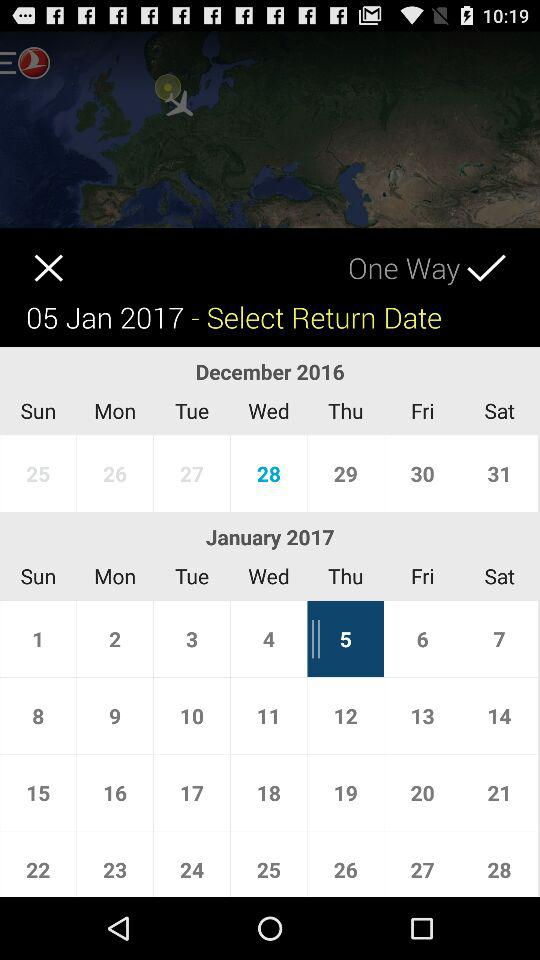What is the selected date? The selected date is Thursday, January 5, 2017. 